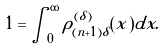Convert formula to latex. <formula><loc_0><loc_0><loc_500><loc_500>1 = \int _ { 0 } ^ { \infty } \rho ^ { ( \delta ) } _ { ( n + 1 ) \delta } ( x ) d x .</formula> 